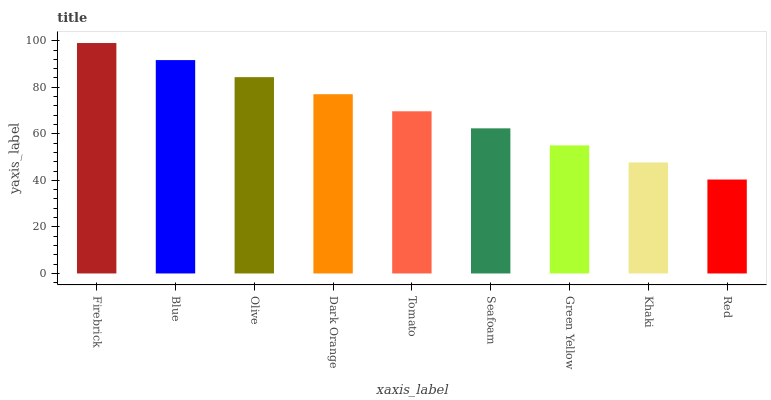Is Red the minimum?
Answer yes or no. Yes. Is Firebrick the maximum?
Answer yes or no. Yes. Is Blue the minimum?
Answer yes or no. No. Is Blue the maximum?
Answer yes or no. No. Is Firebrick greater than Blue?
Answer yes or no. Yes. Is Blue less than Firebrick?
Answer yes or no. Yes. Is Blue greater than Firebrick?
Answer yes or no. No. Is Firebrick less than Blue?
Answer yes or no. No. Is Tomato the high median?
Answer yes or no. Yes. Is Tomato the low median?
Answer yes or no. Yes. Is Firebrick the high median?
Answer yes or no. No. Is Olive the low median?
Answer yes or no. No. 